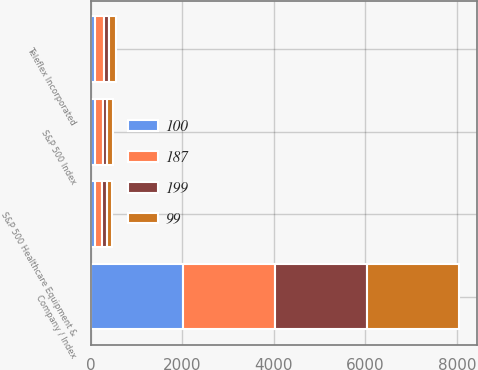Convert chart. <chart><loc_0><loc_0><loc_500><loc_500><stacked_bar_chart><ecel><fcel>Company / Index<fcel>Teleflex Incorporated<fcel>S&P 500 Index<fcel>S&P 500 Healthcare Equipment &<nl><fcel>100<fcel>2010<fcel>100<fcel>100<fcel>100<nl><fcel>199<fcel>2011<fcel>117<fcel>102<fcel>99<nl><fcel>99<fcel>2012<fcel>138<fcel>118<fcel>116<nl><fcel>187<fcel>2013<fcel>185<fcel>157<fcel>148<nl></chart> 